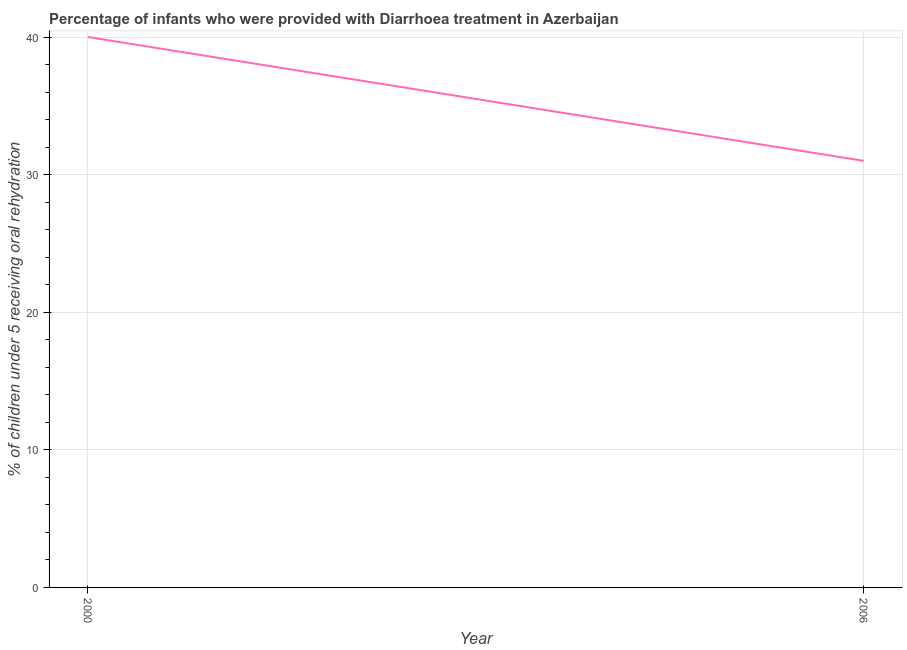What is the percentage of children who were provided with treatment diarrhoea in 2000?
Make the answer very short. 40. Across all years, what is the maximum percentage of children who were provided with treatment diarrhoea?
Give a very brief answer. 40. Across all years, what is the minimum percentage of children who were provided with treatment diarrhoea?
Keep it short and to the point. 31. What is the sum of the percentage of children who were provided with treatment diarrhoea?
Offer a terse response. 71. What is the difference between the percentage of children who were provided with treatment diarrhoea in 2000 and 2006?
Give a very brief answer. 9. What is the average percentage of children who were provided with treatment diarrhoea per year?
Offer a terse response. 35.5. What is the median percentage of children who were provided with treatment diarrhoea?
Give a very brief answer. 35.5. What is the ratio of the percentage of children who were provided with treatment diarrhoea in 2000 to that in 2006?
Offer a very short reply. 1.29. Is the percentage of children who were provided with treatment diarrhoea in 2000 less than that in 2006?
Provide a succinct answer. No. What is the difference between two consecutive major ticks on the Y-axis?
Your answer should be very brief. 10. What is the title of the graph?
Your answer should be very brief. Percentage of infants who were provided with Diarrhoea treatment in Azerbaijan. What is the label or title of the X-axis?
Your answer should be compact. Year. What is the label or title of the Y-axis?
Provide a succinct answer. % of children under 5 receiving oral rehydration. What is the % of children under 5 receiving oral rehydration in 2006?
Provide a short and direct response. 31. What is the difference between the % of children under 5 receiving oral rehydration in 2000 and 2006?
Make the answer very short. 9. What is the ratio of the % of children under 5 receiving oral rehydration in 2000 to that in 2006?
Your answer should be compact. 1.29. 